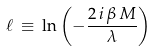<formula> <loc_0><loc_0><loc_500><loc_500>\ell \, \equiv \, \ln \left ( - \frac { 2 \, i \, \beta \, M } { \lambda } \right )</formula> 